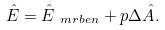<formula> <loc_0><loc_0><loc_500><loc_500>\hat { E } = \hat { E } _ { \ m r b e n } + p \Delta \hat { A } .</formula> 